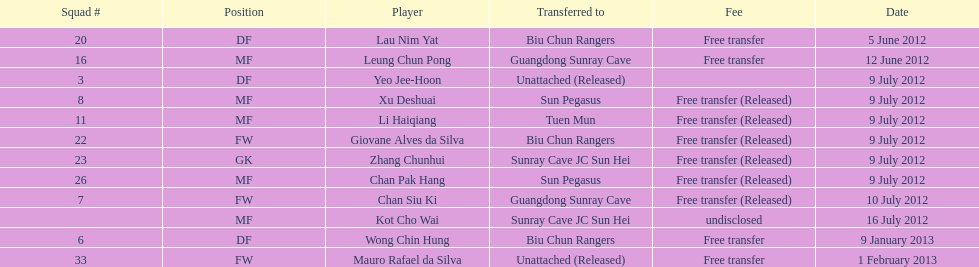What squad # is listed previous to squad # 7? 26. 